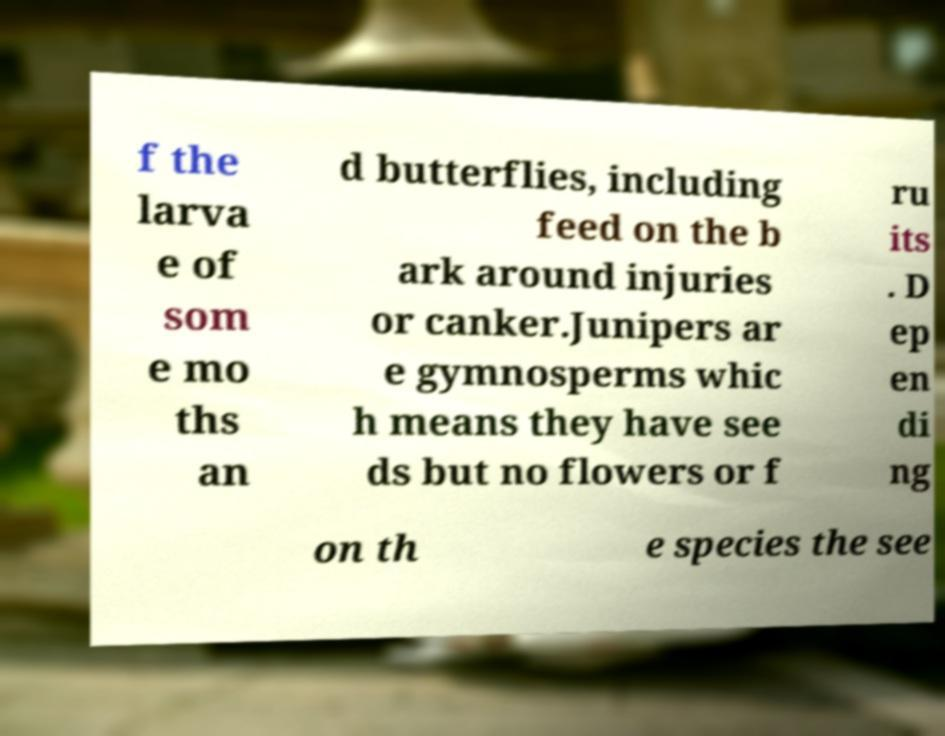Can you read and provide the text displayed in the image?This photo seems to have some interesting text. Can you extract and type it out for me? f the larva e of som e mo ths an d butterflies, including feed on the b ark around injuries or canker.Junipers ar e gymnosperms whic h means they have see ds but no flowers or f ru its . D ep en di ng on th e species the see 